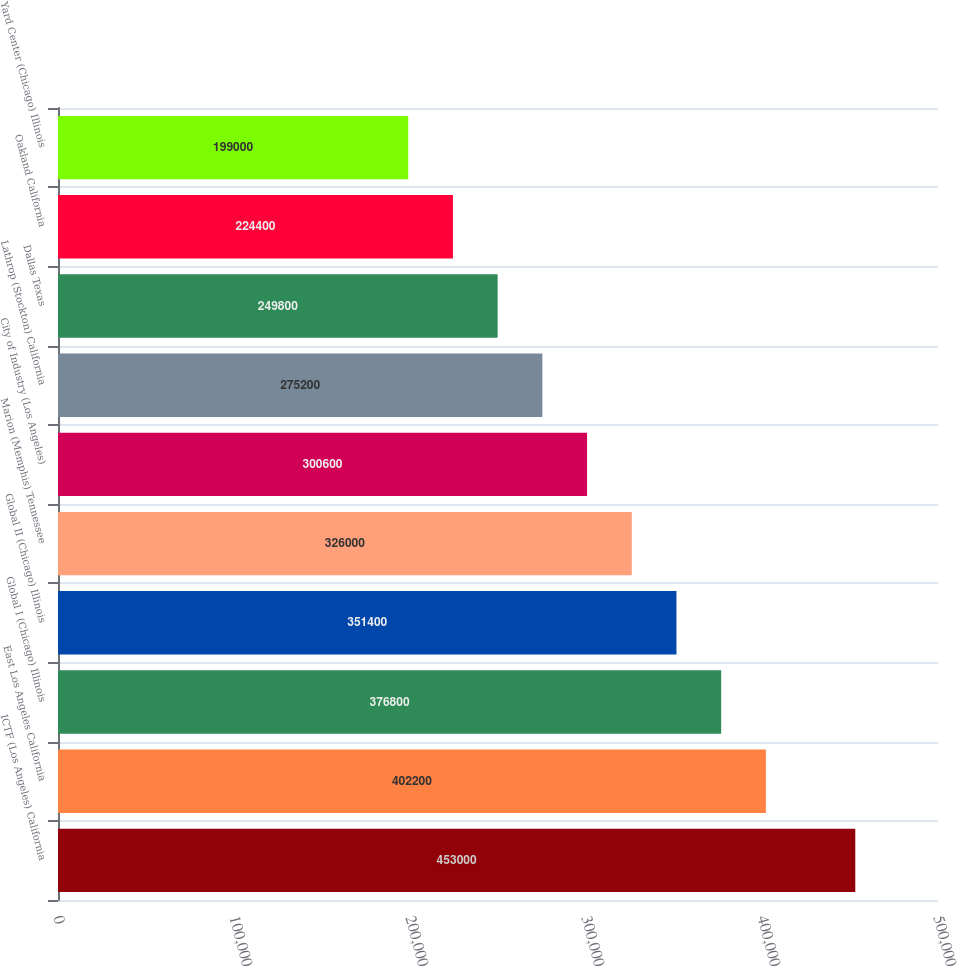<chart> <loc_0><loc_0><loc_500><loc_500><bar_chart><fcel>ICTF (Los Angeles) California<fcel>East Los Angeles California<fcel>Global I (Chicago) Illinois<fcel>Global II (Chicago) Illinois<fcel>Marion (Memphis) Tennessee<fcel>City of Industry (Los Angeles)<fcel>Lathrop (Stockton) California<fcel>Dallas Texas<fcel>Oakland California<fcel>Yard Center (Chicago) Illinois<nl><fcel>453000<fcel>402200<fcel>376800<fcel>351400<fcel>326000<fcel>300600<fcel>275200<fcel>249800<fcel>224400<fcel>199000<nl></chart> 